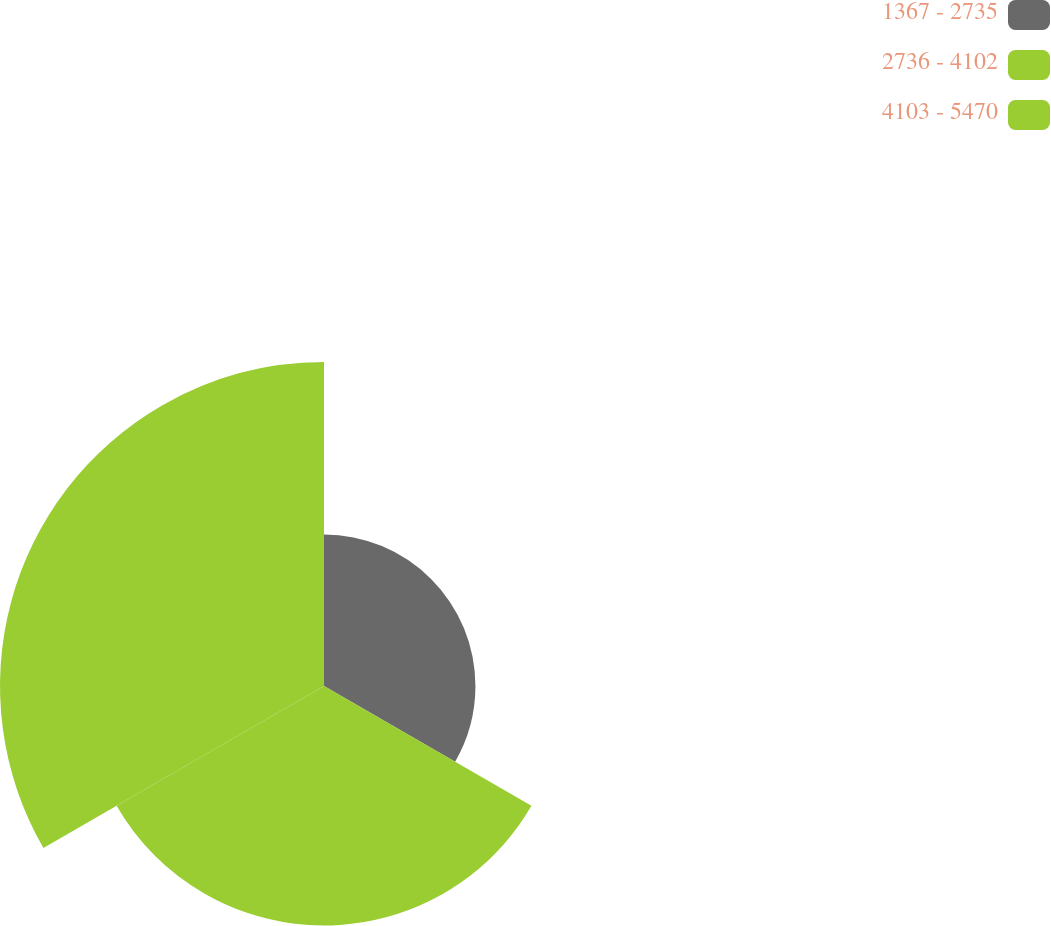Convert chart to OTSL. <chart><loc_0><loc_0><loc_500><loc_500><pie_chart><fcel>1367 - 2735<fcel>2736 - 4102<fcel>4103 - 5470<nl><fcel>21.18%<fcel>33.5%<fcel>45.32%<nl></chart> 